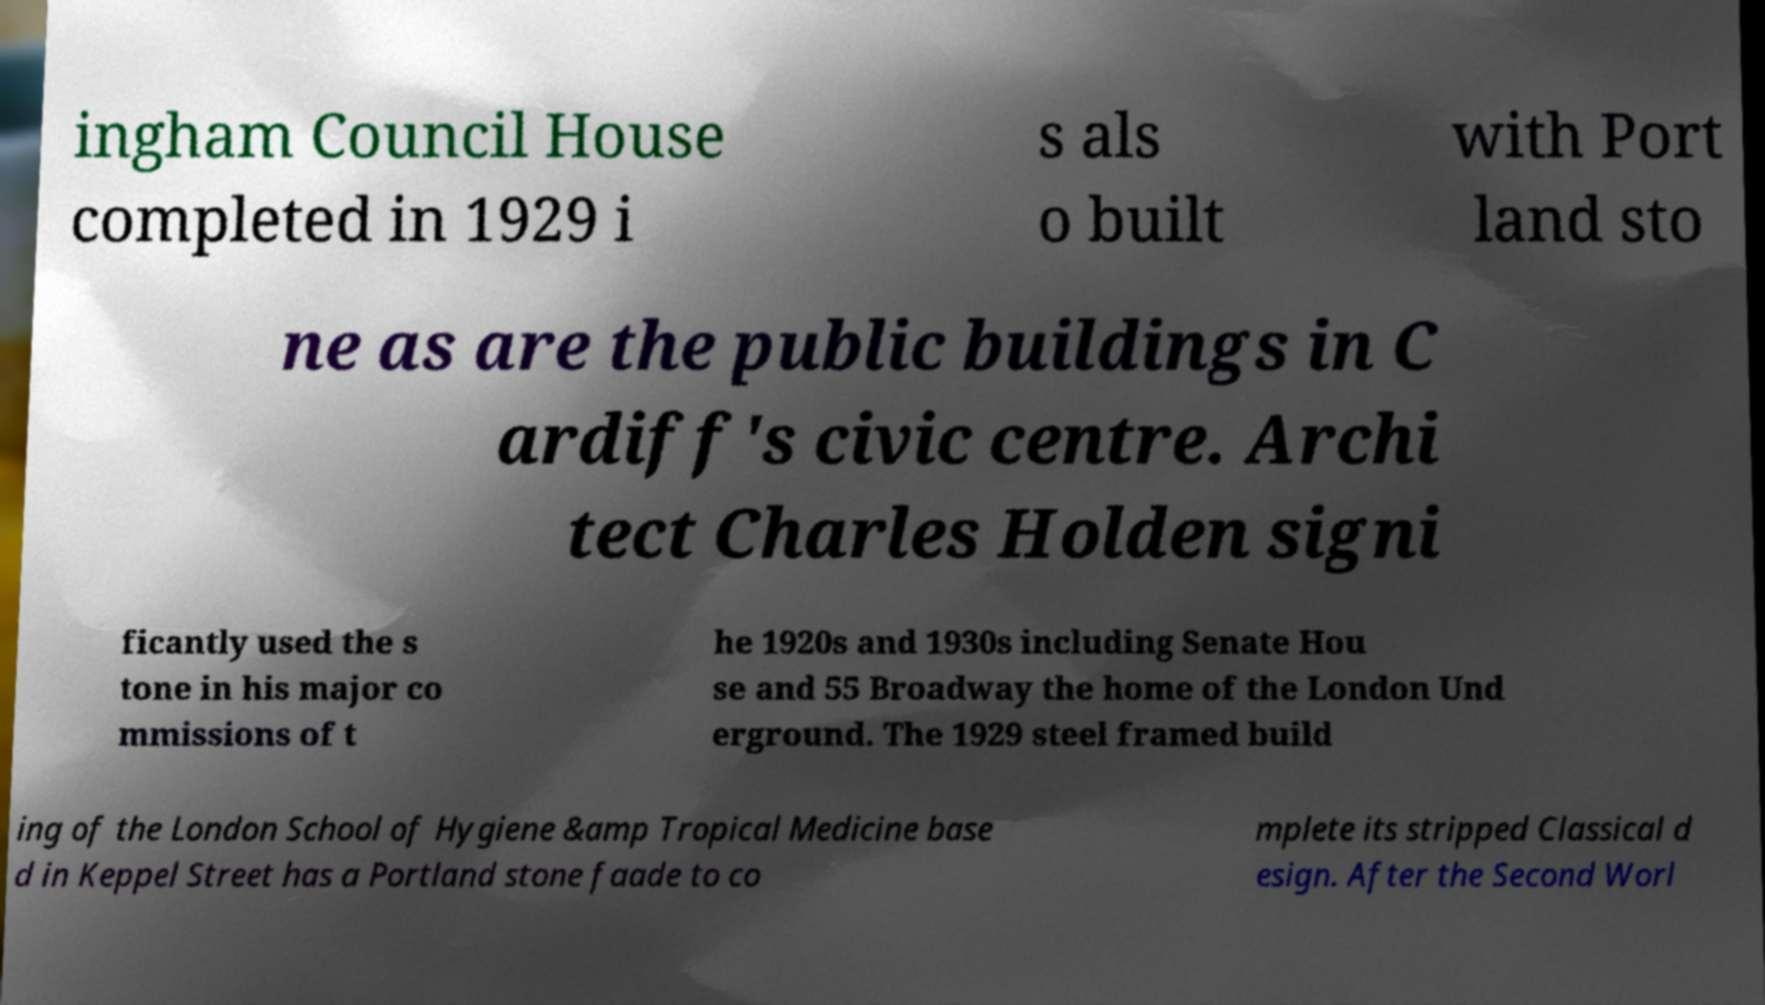For documentation purposes, I need the text within this image transcribed. Could you provide that? ingham Council House completed in 1929 i s als o built with Port land sto ne as are the public buildings in C ardiff's civic centre. Archi tect Charles Holden signi ficantly used the s tone in his major co mmissions of t he 1920s and 1930s including Senate Hou se and 55 Broadway the home of the London Und erground. The 1929 steel framed build ing of the London School of Hygiene &amp Tropical Medicine base d in Keppel Street has a Portland stone faade to co mplete its stripped Classical d esign. After the Second Worl 